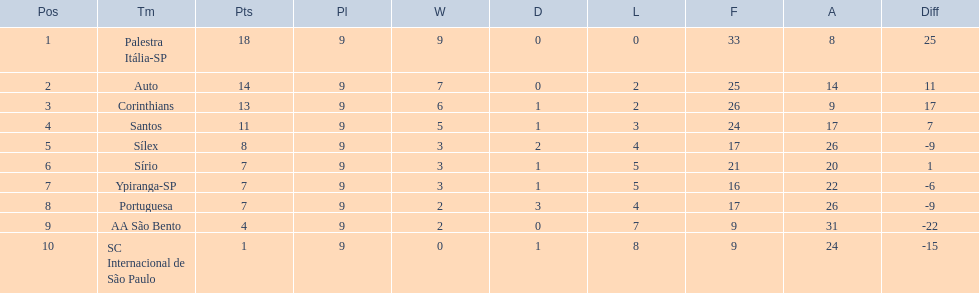What are all the teams? Palestra Itália-SP, Auto, Corinthians, Santos, Sílex, Sírio, Ypiranga-SP, Portuguesa, AA São Bento, SC Internacional de São Paulo. How many times did each team lose? 0, 2, 2, 3, 4, 5, 5, 4, 7, 8. And which team never lost? Palestra Itália-SP. 